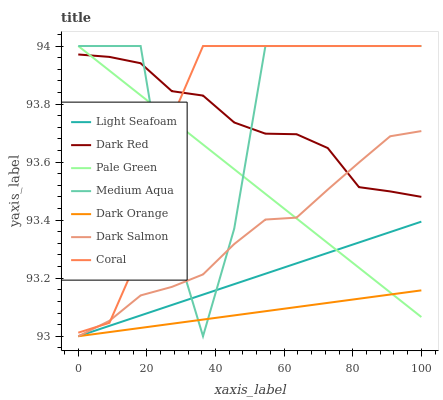Does Dark Orange have the minimum area under the curve?
Answer yes or no. Yes. Does Medium Aqua have the maximum area under the curve?
Answer yes or no. Yes. Does Dark Red have the minimum area under the curve?
Answer yes or no. No. Does Dark Red have the maximum area under the curve?
Answer yes or no. No. Is Dark Orange the smoothest?
Answer yes or no. Yes. Is Medium Aqua the roughest?
Answer yes or no. Yes. Is Dark Red the smoothest?
Answer yes or no. No. Is Dark Red the roughest?
Answer yes or no. No. Does Dark Orange have the lowest value?
Answer yes or no. Yes. Does Coral have the lowest value?
Answer yes or no. No. Does Medium Aqua have the highest value?
Answer yes or no. Yes. Does Dark Red have the highest value?
Answer yes or no. No. Is Dark Orange less than Coral?
Answer yes or no. Yes. Is Coral greater than Dark Orange?
Answer yes or no. Yes. Does Pale Green intersect Dark Red?
Answer yes or no. Yes. Is Pale Green less than Dark Red?
Answer yes or no. No. Is Pale Green greater than Dark Red?
Answer yes or no. No. Does Dark Orange intersect Coral?
Answer yes or no. No. 